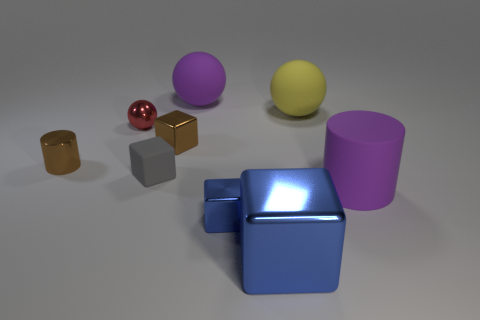There is a metallic cube that is the same color as the tiny metallic cylinder; what is its size?
Provide a short and direct response. Small. What number of blocks are matte objects or brown things?
Ensure brevity in your answer.  2. What is the size of the metal cylinder?
Your answer should be compact. Small. There is a big purple cylinder; what number of tiny gray objects are in front of it?
Provide a short and direct response. 0. How big is the brown object in front of the brown object that is on the right side of the tiny ball?
Provide a succinct answer. Small. Do the purple rubber object in front of the tiny brown metallic cylinder and the brown metallic object to the left of the tiny gray rubber object have the same shape?
Provide a short and direct response. Yes. What shape is the big purple object that is on the right side of the big rubber thing behind the big yellow ball?
Provide a succinct answer. Cylinder. There is a cube that is right of the tiny gray object and behind the tiny blue shiny cube; how big is it?
Give a very brief answer. Small. Does the small red metal object have the same shape as the large blue object that is in front of the gray matte block?
Give a very brief answer. No. What size is the red object that is the same shape as the big yellow rubber thing?
Your answer should be very brief. Small. 